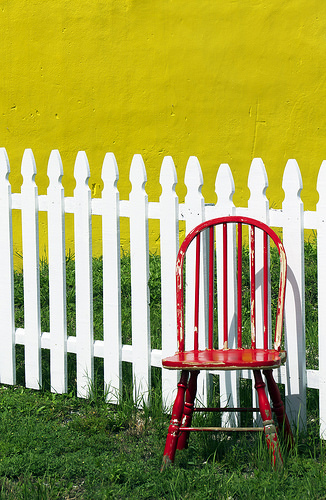<image>
Is the chair behind the fence? Yes. From this viewpoint, the chair is positioned behind the fence, with the fence partially or fully occluding the chair. Where is the chair in relation to the fence? Is it in front of the fence? Yes. The chair is positioned in front of the fence, appearing closer to the camera viewpoint. 